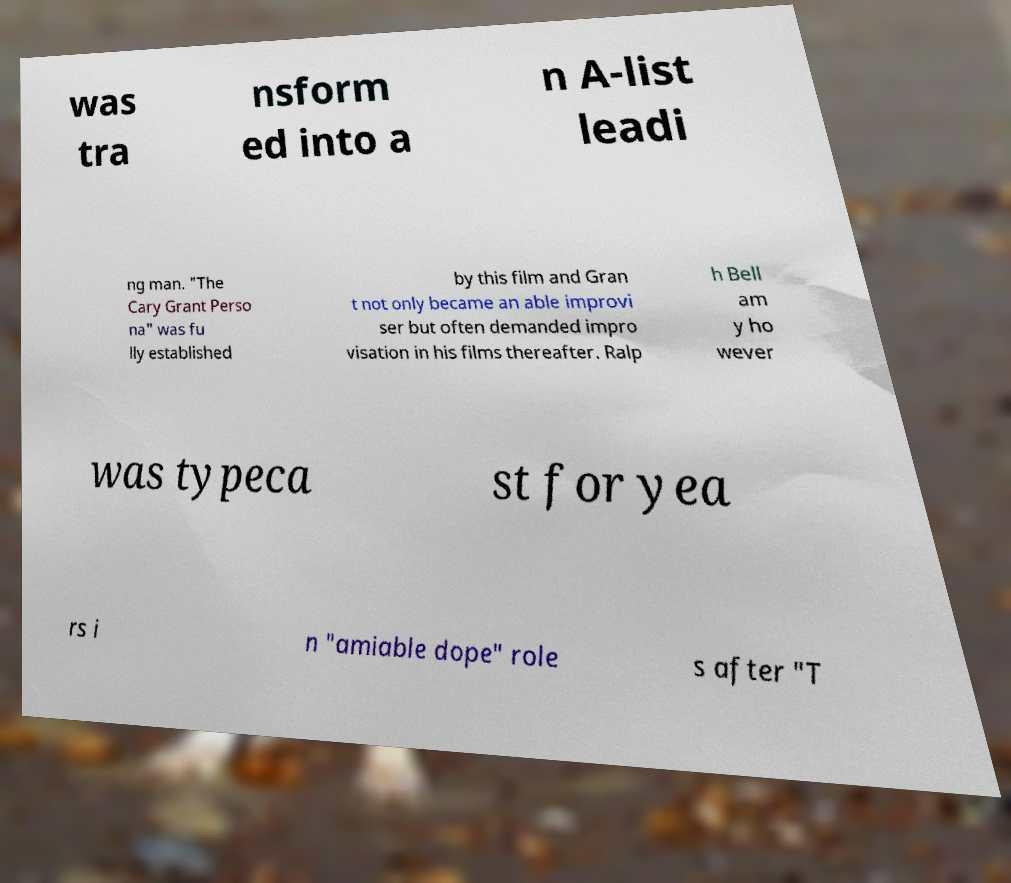For documentation purposes, I need the text within this image transcribed. Could you provide that? was tra nsform ed into a n A-list leadi ng man. "The Cary Grant Perso na" was fu lly established by this film and Gran t not only became an able improvi ser but often demanded impro visation in his films thereafter. Ralp h Bell am y ho wever was typeca st for yea rs i n "amiable dope" role s after "T 